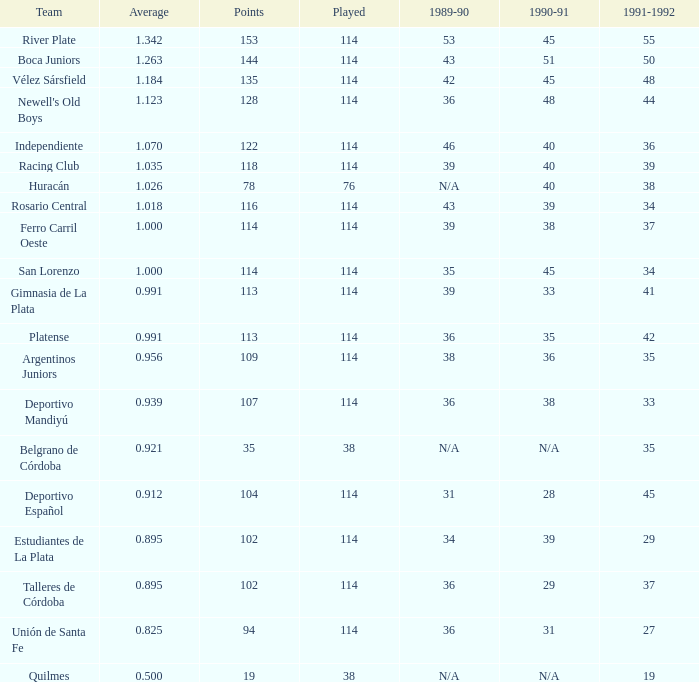During the 1991-1992 season, how many points did the gimnasia de la plata team accumulate, and was it more than 113 points? 0.0. 